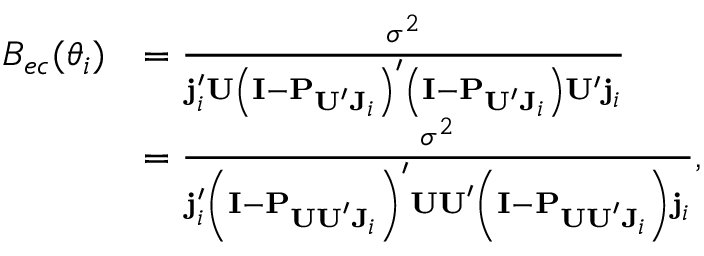Convert formula to latex. <formula><loc_0><loc_0><loc_500><loc_500>\begin{array} { r l } { B _ { e c } ( \boldsymbol \theta _ { i } ) } & { = \frac { \sigma ^ { 2 } } { j _ { i } ^ { \prime } U \left ( I - P _ { U ^ { \prime } J _ { i } } \right ) ^ { \prime } \left ( I - P _ { U ^ { \prime } J _ { i } } \right ) U ^ { \prime } j _ { i } } } \\ & { = \frac { \sigma ^ { 2 } } { j _ { i } ^ { \prime } \left ( I - P _ { U U ^ { \prime } J _ { i } } \right ) ^ { \prime } U U ^ { \prime } \left ( I - P _ { U U ^ { \prime } J _ { i } } \right ) j _ { i } } , } \end{array}</formula> 